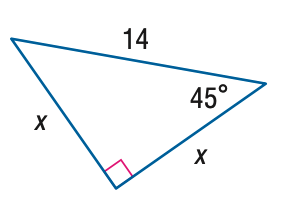Answer the mathemtical geometry problem and directly provide the correct option letter.
Question: Find x.
Choices: A: 7 B: 7 \sqrt { 2 } C: 7 \sqrt { 3 } D: 14 B 